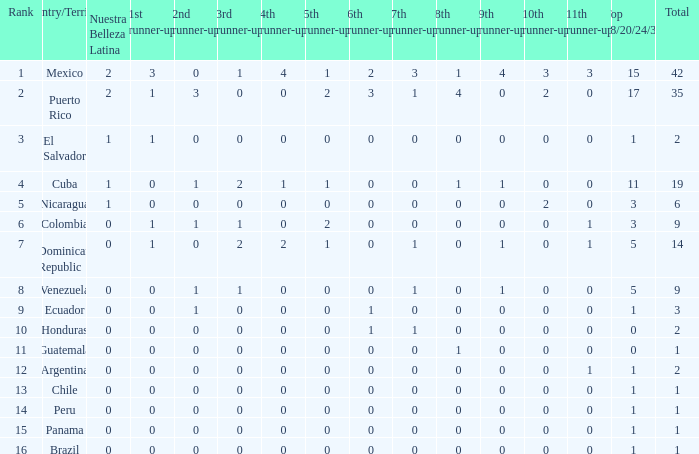I'm looking to parse the entire table for insights. Could you assist me with that? {'header': ['Rank', 'Country/Territory', 'Nuestra Belleza Latina', '1st runner-up', '2nd runner-up', '3rd runner-up', '4th runner-up', '5th runner-up', '6th runner-up', '7th runner-up', '8th runner-up', '9th runner-up', '10th runner-up', '11th runner-up', 'Top 18/20/24/30', 'Total'], 'rows': [['1', 'Mexico', '2', '3', '0', '1', '4', '1', '2', '3', '1', '4', '3', '3', '15', '42'], ['2', 'Puerto Rico', '2', '1', '3', '0', '0', '2', '3', '1', '4', '0', '2', '0', '17', '35'], ['3', 'El Salvador', '1', '1', '0', '0', '0', '0', '0', '0', '0', '0', '0', '0', '1', '2'], ['4', 'Cuba', '1', '0', '1', '2', '1', '1', '0', '0', '1', '1', '0', '0', '11', '19'], ['5', 'Nicaragua', '1', '0', '0', '0', '0', '0', '0', '0', '0', '0', '2', '0', '3', '6'], ['6', 'Colombia', '0', '1', '1', '1', '0', '2', '0', '0', '0', '0', '0', '1', '3', '9'], ['7', 'Dominican Republic', '0', '1', '0', '2', '2', '1', '0', '1', '0', '1', '0', '1', '5', '14'], ['8', 'Venezuela', '0', '0', '1', '1', '0', '0', '0', '1', '0', '1', '0', '0', '5', '9'], ['9', 'Ecuador', '0', '0', '1', '0', '0', '0', '1', '0', '0', '0', '0', '0', '1', '3'], ['10', 'Honduras', '0', '0', '0', '0', '0', '0', '1', '1', '0', '0', '0', '0', '0', '2'], ['11', 'Guatemala', '0', '0', '0', '0', '0', '0', '0', '0', '1', '0', '0', '0', '0', '1'], ['12', 'Argentina', '0', '0', '0', '0', '0', '0', '0', '0', '0', '0', '0', '1', '1', '2'], ['13', 'Chile', '0', '0', '0', '0', '0', '0', '0', '0', '0', '0', '0', '0', '1', '1'], ['14', 'Peru', '0', '0', '0', '0', '0', '0', '0', '0', '0', '0', '0', '0', '1', '1'], ['15', 'Panama', '0', '0', '0', '0', '0', '0', '0', '0', '0', '0', '0', '0', '1', '1'], ['16', 'Brazil', '0', '0', '0', '0', '0', '0', '0', '0', '0', '0', '0', '0', '1', '1']]} What is the lowest 7th runner-up of the country with a top 18/20/24/30 greater than 5, a 1st runner-up greater than 0, and an 11th runner-up less than 0? None. 